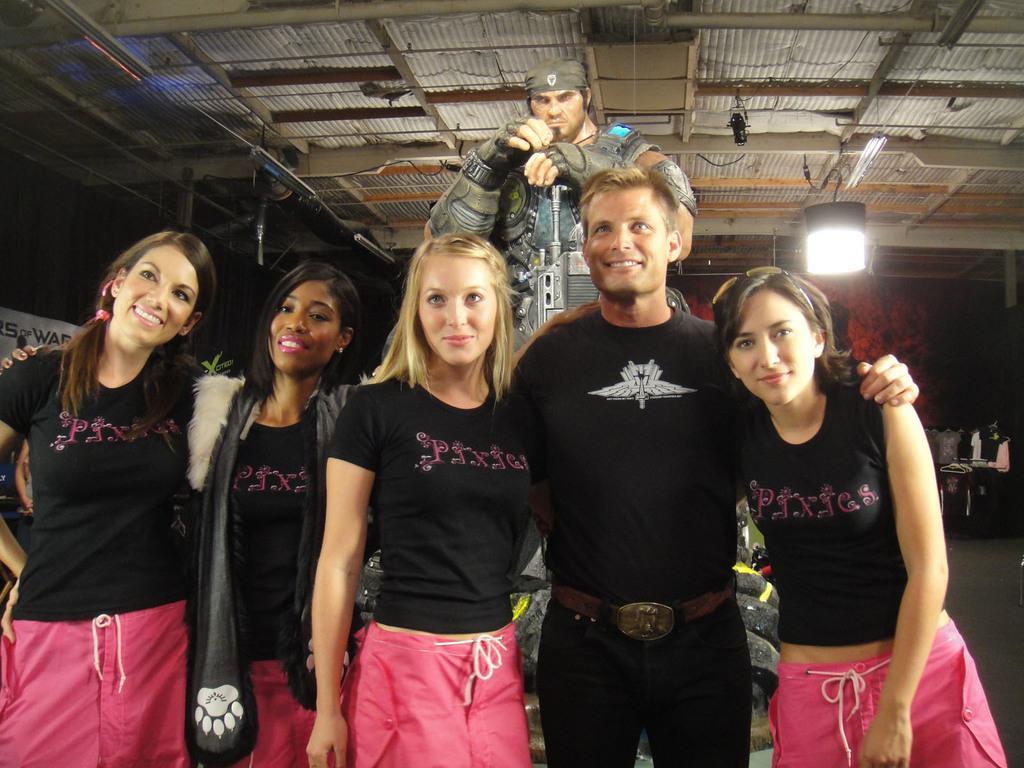Describe this image in one or two sentences. In the center of the image there are people standing wearing black color dress. In the background of the image there is a depiction of a person. At the top of the image there is a roof. 